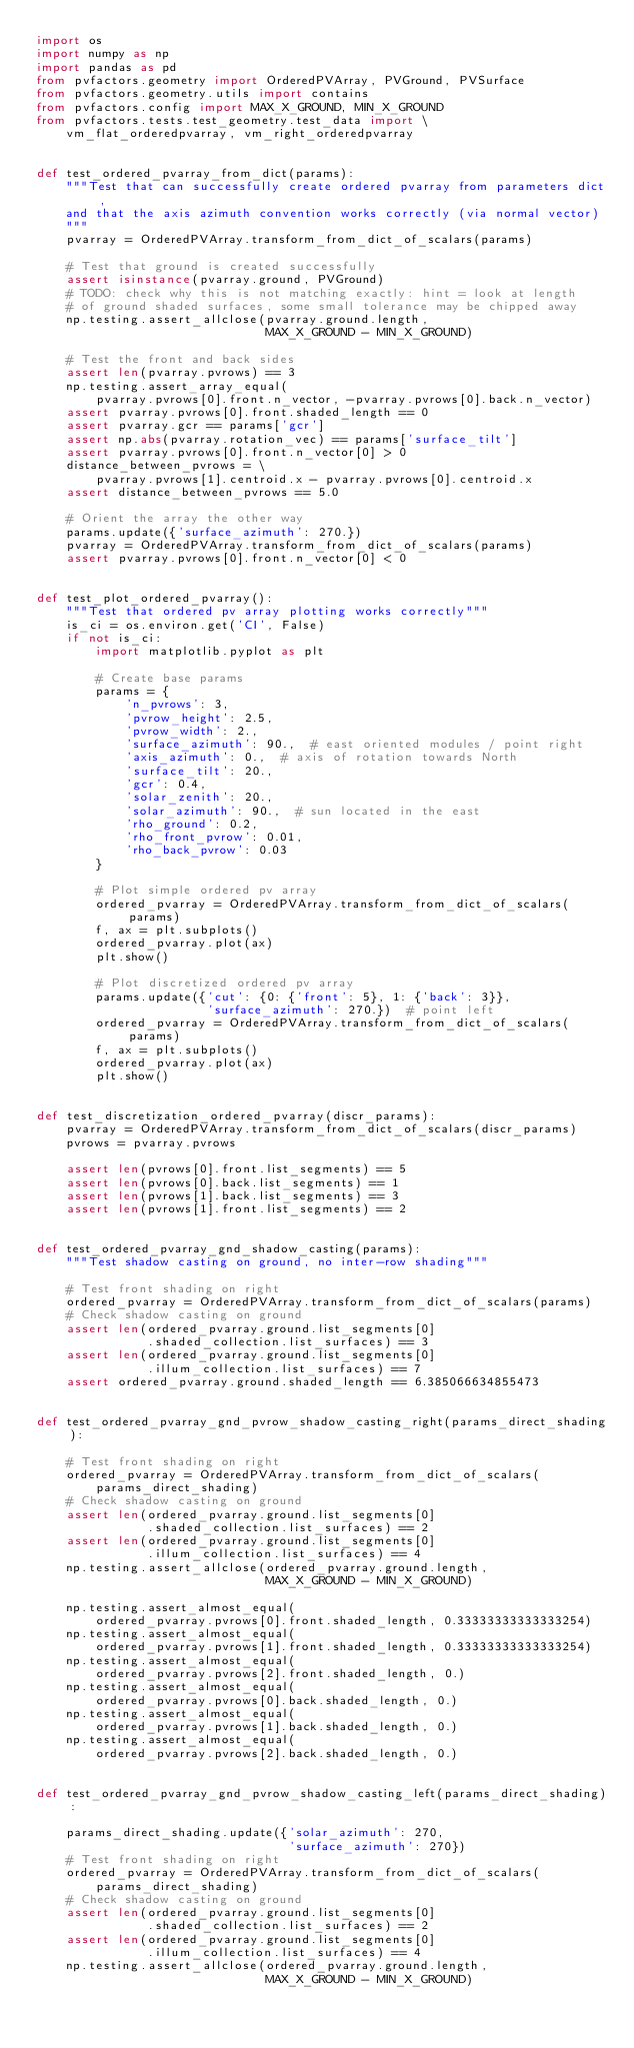Convert code to text. <code><loc_0><loc_0><loc_500><loc_500><_Python_>import os
import numpy as np
import pandas as pd
from pvfactors.geometry import OrderedPVArray, PVGround, PVSurface
from pvfactors.geometry.utils import contains
from pvfactors.config import MAX_X_GROUND, MIN_X_GROUND
from pvfactors.tests.test_geometry.test_data import \
    vm_flat_orderedpvarray, vm_right_orderedpvarray


def test_ordered_pvarray_from_dict(params):
    """Test that can successfully create ordered pvarray from parameters dict,
    and that the axis azimuth convention works correctly (via normal vector)
    """
    pvarray = OrderedPVArray.transform_from_dict_of_scalars(params)

    # Test that ground is created successfully
    assert isinstance(pvarray.ground, PVGround)
    # TODO: check why this is not matching exactly: hint = look at length
    # of ground shaded surfaces, some small tolerance may be chipped away
    np.testing.assert_allclose(pvarray.ground.length,
                               MAX_X_GROUND - MIN_X_GROUND)

    # Test the front and back sides
    assert len(pvarray.pvrows) == 3
    np.testing.assert_array_equal(
        pvarray.pvrows[0].front.n_vector, -pvarray.pvrows[0].back.n_vector)
    assert pvarray.pvrows[0].front.shaded_length == 0
    assert pvarray.gcr == params['gcr']
    assert np.abs(pvarray.rotation_vec) == params['surface_tilt']
    assert pvarray.pvrows[0].front.n_vector[0] > 0
    distance_between_pvrows = \
        pvarray.pvrows[1].centroid.x - pvarray.pvrows[0].centroid.x
    assert distance_between_pvrows == 5.0

    # Orient the array the other way
    params.update({'surface_azimuth': 270.})
    pvarray = OrderedPVArray.transform_from_dict_of_scalars(params)
    assert pvarray.pvrows[0].front.n_vector[0] < 0


def test_plot_ordered_pvarray():
    """Test that ordered pv array plotting works correctly"""
    is_ci = os.environ.get('CI', False)
    if not is_ci:
        import matplotlib.pyplot as plt

        # Create base params
        params = {
            'n_pvrows': 3,
            'pvrow_height': 2.5,
            'pvrow_width': 2.,
            'surface_azimuth': 90.,  # east oriented modules / point right
            'axis_azimuth': 0.,  # axis of rotation towards North
            'surface_tilt': 20.,
            'gcr': 0.4,
            'solar_zenith': 20.,
            'solar_azimuth': 90.,  # sun located in the east
            'rho_ground': 0.2,
            'rho_front_pvrow': 0.01,
            'rho_back_pvrow': 0.03
        }

        # Plot simple ordered pv array
        ordered_pvarray = OrderedPVArray.transform_from_dict_of_scalars(params)
        f, ax = plt.subplots()
        ordered_pvarray.plot(ax)
        plt.show()

        # Plot discretized ordered pv array
        params.update({'cut': {0: {'front': 5}, 1: {'back': 3}},
                       'surface_azimuth': 270.})  # point left
        ordered_pvarray = OrderedPVArray.transform_from_dict_of_scalars(params)
        f, ax = plt.subplots()
        ordered_pvarray.plot(ax)
        plt.show()


def test_discretization_ordered_pvarray(discr_params):
    pvarray = OrderedPVArray.transform_from_dict_of_scalars(discr_params)
    pvrows = pvarray.pvrows

    assert len(pvrows[0].front.list_segments) == 5
    assert len(pvrows[0].back.list_segments) == 1
    assert len(pvrows[1].back.list_segments) == 3
    assert len(pvrows[1].front.list_segments) == 2


def test_ordered_pvarray_gnd_shadow_casting(params):
    """Test shadow casting on ground, no inter-row shading"""

    # Test front shading on right
    ordered_pvarray = OrderedPVArray.transform_from_dict_of_scalars(params)
    # Check shadow casting on ground
    assert len(ordered_pvarray.ground.list_segments[0]
               .shaded_collection.list_surfaces) == 3
    assert len(ordered_pvarray.ground.list_segments[0]
               .illum_collection.list_surfaces) == 7
    assert ordered_pvarray.ground.shaded_length == 6.385066634855473


def test_ordered_pvarray_gnd_pvrow_shadow_casting_right(params_direct_shading):

    # Test front shading on right
    ordered_pvarray = OrderedPVArray.transform_from_dict_of_scalars(
        params_direct_shading)
    # Check shadow casting on ground
    assert len(ordered_pvarray.ground.list_segments[0]
               .shaded_collection.list_surfaces) == 2
    assert len(ordered_pvarray.ground.list_segments[0]
               .illum_collection.list_surfaces) == 4
    np.testing.assert_allclose(ordered_pvarray.ground.length,
                               MAX_X_GROUND - MIN_X_GROUND)

    np.testing.assert_almost_equal(
        ordered_pvarray.pvrows[0].front.shaded_length, 0.33333333333333254)
    np.testing.assert_almost_equal(
        ordered_pvarray.pvrows[1].front.shaded_length, 0.33333333333333254)
    np.testing.assert_almost_equal(
        ordered_pvarray.pvrows[2].front.shaded_length, 0.)
    np.testing.assert_almost_equal(
        ordered_pvarray.pvrows[0].back.shaded_length, 0.)
    np.testing.assert_almost_equal(
        ordered_pvarray.pvrows[1].back.shaded_length, 0.)
    np.testing.assert_almost_equal(
        ordered_pvarray.pvrows[2].back.shaded_length, 0.)


def test_ordered_pvarray_gnd_pvrow_shadow_casting_left(params_direct_shading):

    params_direct_shading.update({'solar_azimuth': 270,
                                  'surface_azimuth': 270})
    # Test front shading on right
    ordered_pvarray = OrderedPVArray.transform_from_dict_of_scalars(
        params_direct_shading)
    # Check shadow casting on ground
    assert len(ordered_pvarray.ground.list_segments[0]
               .shaded_collection.list_surfaces) == 2
    assert len(ordered_pvarray.ground.list_segments[0]
               .illum_collection.list_surfaces) == 4
    np.testing.assert_allclose(ordered_pvarray.ground.length,
                               MAX_X_GROUND - MIN_X_GROUND)
</code> 